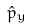<formula> <loc_0><loc_0><loc_500><loc_500>\hat { p } _ { y }</formula> 